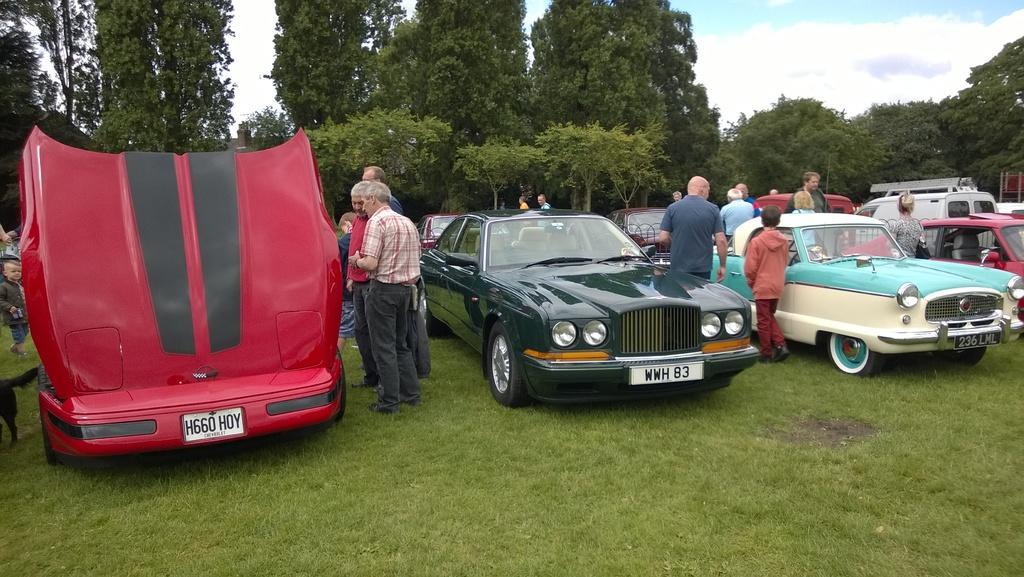Could you give a brief overview of what you see in this image? This is an outside view. At the bottom, I can see the grass on the ground. In the middle of the image there are few cars and few people are standing. In the background there are many trees. At the top of the image I can see the sky and clouds.. 